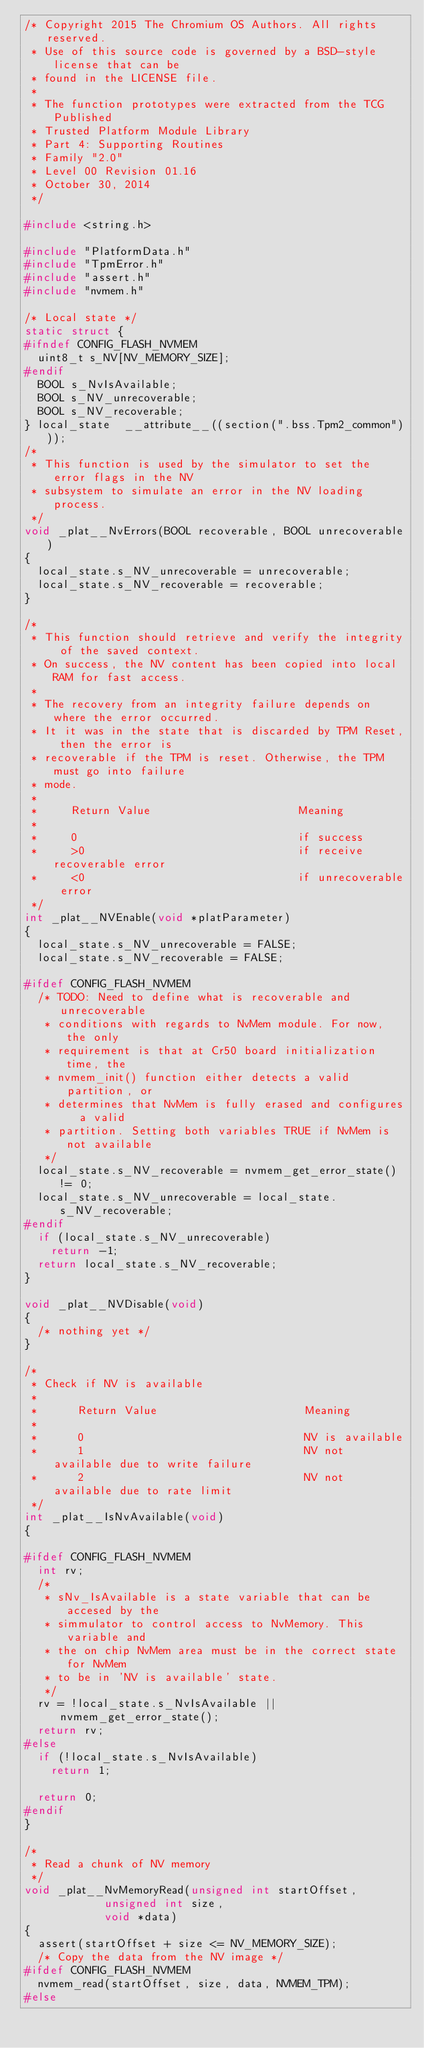Convert code to text. <code><loc_0><loc_0><loc_500><loc_500><_C_>/* Copyright 2015 The Chromium OS Authors. All rights reserved.
 * Use of this source code is governed by a BSD-style license that can be
 * found in the LICENSE file.
 *
 * The function prototypes were extracted from the TCG Published
 * Trusted Platform Module Library
 * Part 4: Supporting Routines
 * Family "2.0"
 * Level 00 Revision 01.16
 * October 30, 2014
 */

#include <string.h>

#include "PlatformData.h"
#include "TpmError.h"
#include "assert.h"
#include "nvmem.h"

/* Local state */
static struct {
#ifndef CONFIG_FLASH_NVMEM
	uint8_t s_NV[NV_MEMORY_SIZE];
#endif
	BOOL s_NvIsAvailable;
	BOOL s_NV_unrecoverable;
	BOOL s_NV_recoverable;
} local_state  __attribute__((section(".bss.Tpm2_common")));
/*
 * This function is used by the simulator to set the error flags in the NV
 * subsystem to simulate an error in the NV loading process.
 */
void _plat__NvErrors(BOOL recoverable, BOOL unrecoverable)
{
	local_state.s_NV_unrecoverable = unrecoverable;
	local_state.s_NV_recoverable = recoverable;
}

/*
 * This function should retrieve and verify the integrity of the saved context.
 * On success, the NV content has been copied into local RAM for fast access.
 *
 * The recovery from an integrity failure depends on where the error occurred.
 * It it was in the state that is discarded by TPM Reset, then the error is
 * recoverable if the TPM is reset. Otherwise, the TPM must go into failure
 * mode.
 *
 *     Return Value                      Meaning
 *
 *     0                                 if success
 *     >0                                if receive recoverable error
 *     <0                                if unrecoverable error
 */
int _plat__NVEnable(void *platParameter)
{
	local_state.s_NV_unrecoverable = FALSE;
	local_state.s_NV_recoverable = FALSE;

#ifdef CONFIG_FLASH_NVMEM
	/* TODO: Need to define what is recoverable and unrecoverable
	 * conditions with regards to NvMem module. For now, the only
	 * requirement is that at Cr50 board initialization time, the
	 * nvmem_init() function either detects a valid partition, or
	 * determines that NvMem is fully erased and configures  a valid
	 * partition. Setting both variables TRUE if NvMem is not available
	 */
	local_state.s_NV_recoverable = nvmem_get_error_state() != 0;
	local_state.s_NV_unrecoverable = local_state.s_NV_recoverable;
#endif
	if (local_state.s_NV_unrecoverable)
		return -1;
	return local_state.s_NV_recoverable;
}

void _plat__NVDisable(void)
{
	/* nothing yet */
}

/*
 * Check if NV is available
 *
 *      Return Value                      Meaning
 *
 *      0                                 NV is available
 *      1                                 NV not available due to write failure
 *      2                                 NV not available due to rate limit
 */
int _plat__IsNvAvailable(void)
{

#ifdef CONFIG_FLASH_NVMEM
	int rv;
	/*
	 * sNv_IsAvailable is a state variable that can be accesed by the
	 * simmulator to control access to NvMemory. This variable and
	 * the on chip NvMem area must be in the correct state for NvMem
	 * to be in 'NV is available' state.
	 */
	rv = !local_state.s_NvIsAvailable || nvmem_get_error_state();
	return rv;
#else
	if (!local_state.s_NvIsAvailable)
		return 1;

	return 0;
#endif
}

/*
 * Read a chunk of NV memory
 */
void _plat__NvMemoryRead(unsigned int startOffset,
				    unsigned int size,
				    void *data)
{
	assert(startOffset + size <= NV_MEMORY_SIZE);
	/* Copy the data from the NV image */
#ifdef CONFIG_FLASH_NVMEM
	nvmem_read(startOffset, size, data, NVMEM_TPM);
#else</code> 